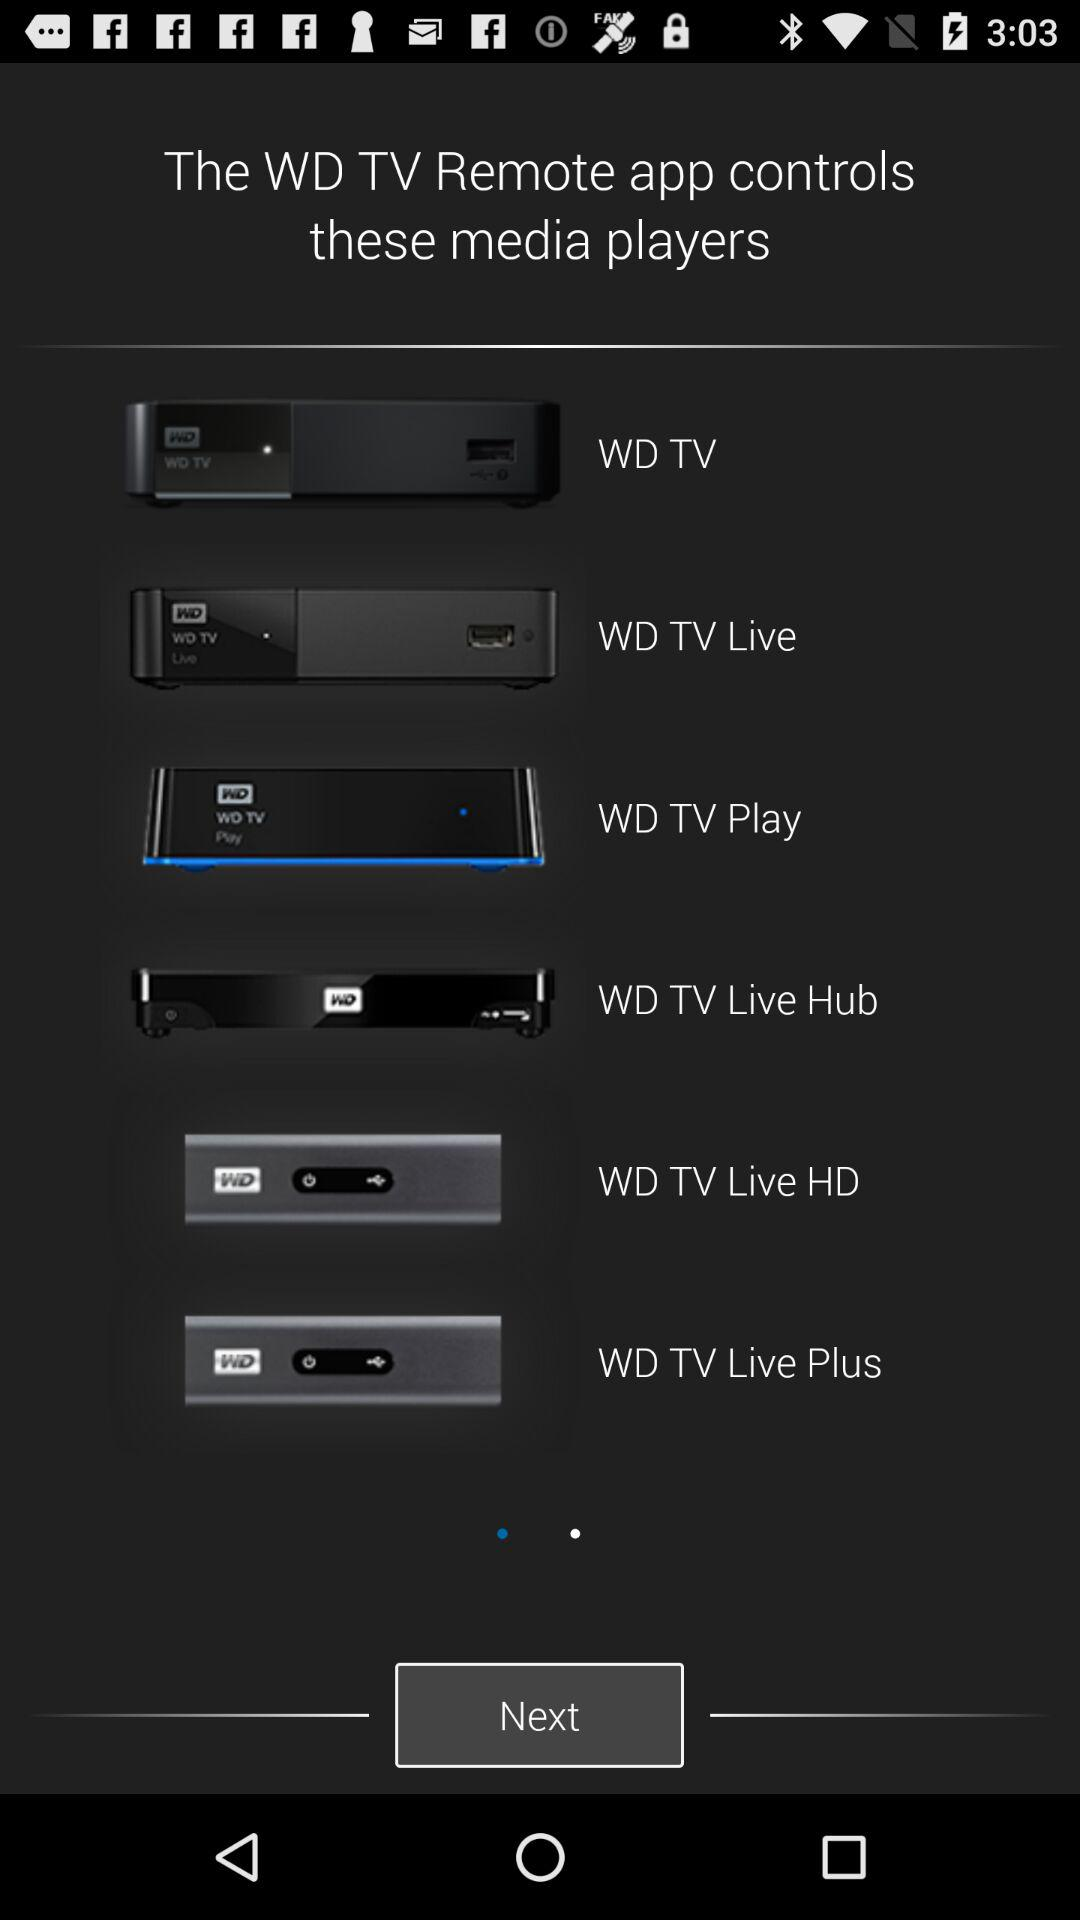What is the name of the application? The name of the application is "WD TV Remote". 